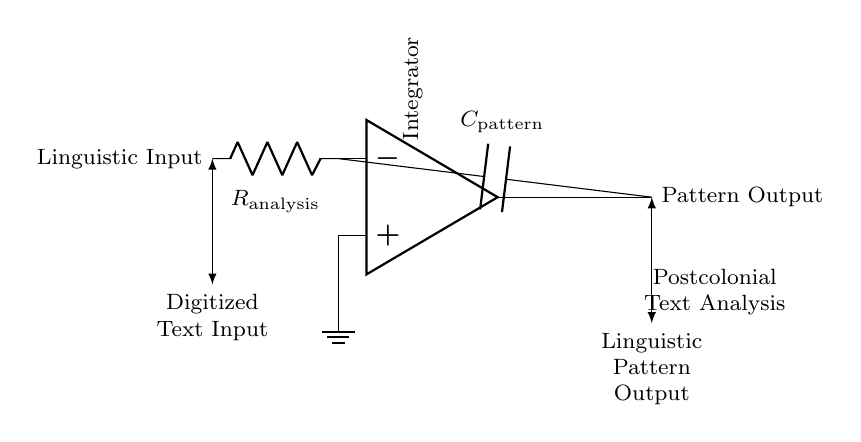What is the main function of this circuit? The main function of this circuit is an integrator, as indicated by the label on the circuit diagram. An integrator processes the input signal to produce an output that represents the accumulated effect over time.
Answer: Integrator What component is labeled as R? The component labeled as R in the circuit is referred to as resistance, specifically labeled as R_analysis. It is used to control the current flow in the circuit.
Answer: Resistance What type of input does this circuit process? The circuit processes digitized text input, as indicated by the labeling next to the input node. This suggests that the circuit takes text data as its input.
Answer: Digitized text What is the output of this integrator circuit? The output of the circuit is labeled as pattern output, which refers to the processed linguistic patterns extracted from the digitized text input.
Answer: Pattern output How do resistor and capacitor work together in this circuit? The resistor R_analysis and capacitor C_pattern work together to form the integrator function. The resistor limits the current, while the capacitor integrates the input voltage over time, leading to an output that is related to the accumulated input.
Answer: Integrate What is C labeled as in the circuit? The component labeled C in the circuit is a capacitor, specifically C_pattern, which is used in the integrator configuration to accumulate charge representing the input signal.
Answer: Capacitor What type of analysis is indicated by the circuit? The circuit indicates postcolonial text analysis. This label shows that the purpose of the integrator circuit is to analyze linguistic patterns specifically in the context of postcolonial literature.
Answer: Postcolonial text analysis 